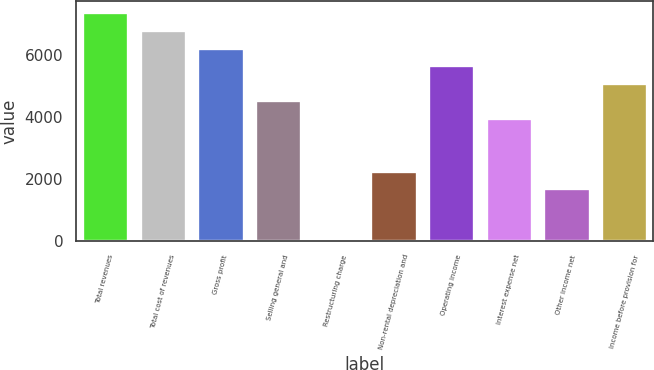Convert chart to OTSL. <chart><loc_0><loc_0><loc_500><loc_500><bar_chart><fcel>Total revenues<fcel>Total cost of revenues<fcel>Gross profit<fcel>Selling general and<fcel>Restructuring charge<fcel>Non-rental depreciation and<fcel>Operating income<fcel>Interest expense net<fcel>Other income net<fcel>Income before provision for<nl><fcel>7390.2<fcel>6821.8<fcel>6253.4<fcel>4548.2<fcel>1<fcel>2274.6<fcel>5685<fcel>3979.8<fcel>1706.2<fcel>5116.6<nl></chart> 